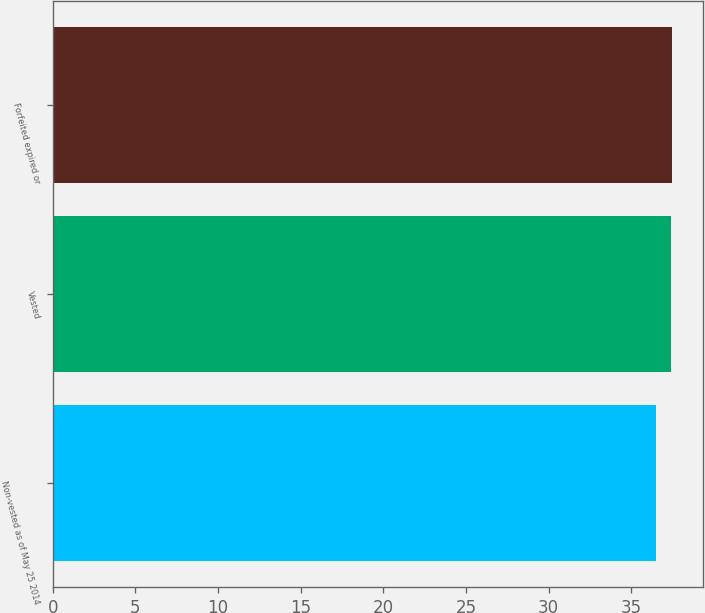<chart> <loc_0><loc_0><loc_500><loc_500><bar_chart><fcel>Non-vested as of May 25 2014<fcel>Vested<fcel>Forfeited expired or<nl><fcel>36.52<fcel>37.4<fcel>37.49<nl></chart> 